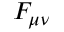<formula> <loc_0><loc_0><loc_500><loc_500>F _ { \mu \nu }</formula> 